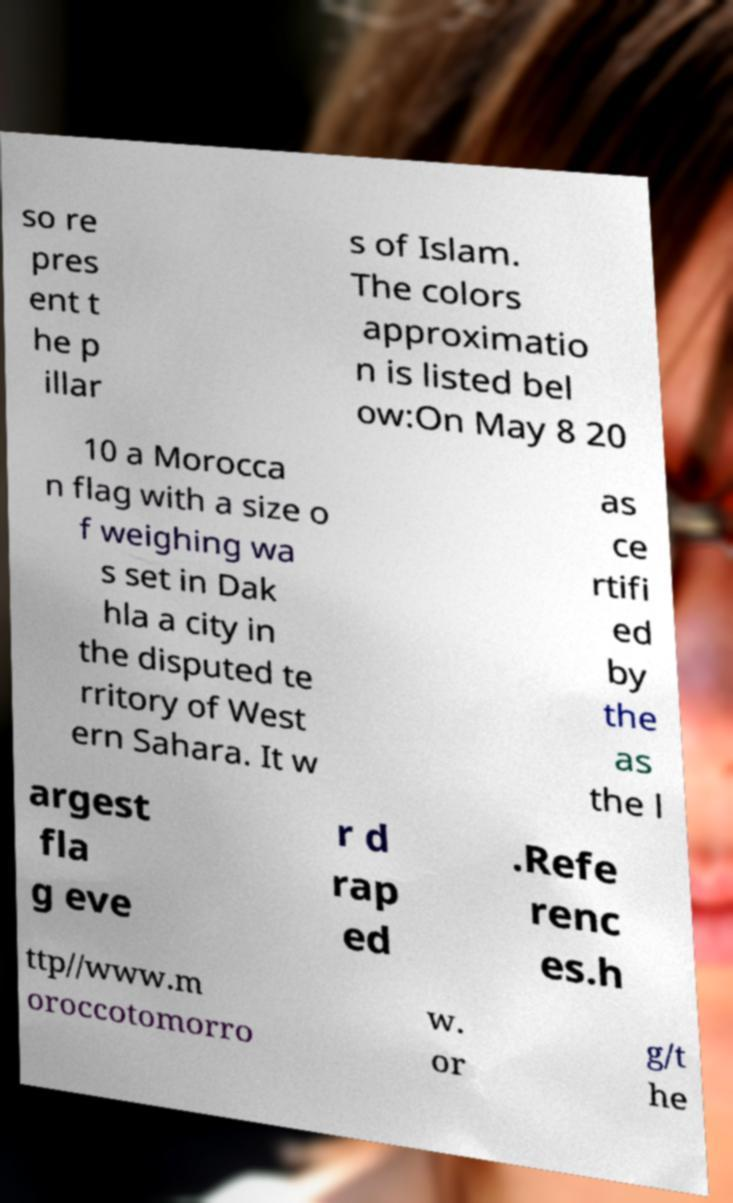For documentation purposes, I need the text within this image transcribed. Could you provide that? so re pres ent t he p illar s of Islam. The colors approximatio n is listed bel ow:On May 8 20 10 a Morocca n flag with a size o f weighing wa s set in Dak hla a city in the disputed te rritory of West ern Sahara. It w as ce rtifi ed by the as the l argest fla g eve r d rap ed .Refe renc es.h ttp//www.m oroccotomorro w. or g/t he 